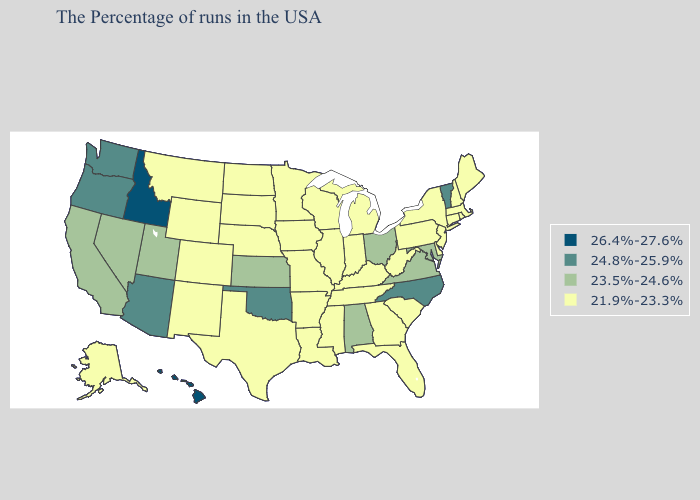How many symbols are there in the legend?
Answer briefly. 4. Which states have the highest value in the USA?
Answer briefly. Idaho, Hawaii. Does North Carolina have the lowest value in the South?
Concise answer only. No. Among the states that border Mississippi , which have the lowest value?
Short answer required. Tennessee, Louisiana, Arkansas. Does Florida have a lower value than North Carolina?
Write a very short answer. Yes. What is the lowest value in the West?
Quick response, please. 21.9%-23.3%. Name the states that have a value in the range 21.9%-23.3%?
Concise answer only. Maine, Massachusetts, Rhode Island, New Hampshire, Connecticut, New York, New Jersey, Delaware, Pennsylvania, South Carolina, West Virginia, Florida, Georgia, Michigan, Kentucky, Indiana, Tennessee, Wisconsin, Illinois, Mississippi, Louisiana, Missouri, Arkansas, Minnesota, Iowa, Nebraska, Texas, South Dakota, North Dakota, Wyoming, Colorado, New Mexico, Montana, Alaska. Does Massachusetts have the same value as Maryland?
Keep it brief. No. Name the states that have a value in the range 24.8%-25.9%?
Be succinct. Vermont, North Carolina, Oklahoma, Arizona, Washington, Oregon. What is the value of Kentucky?
Quick response, please. 21.9%-23.3%. What is the highest value in states that border Louisiana?
Short answer required. 21.9%-23.3%. Among the states that border Illinois , which have the highest value?
Concise answer only. Kentucky, Indiana, Wisconsin, Missouri, Iowa. How many symbols are there in the legend?
Keep it brief. 4. What is the value of Maryland?
Quick response, please. 23.5%-24.6%. What is the value of Iowa?
Write a very short answer. 21.9%-23.3%. 